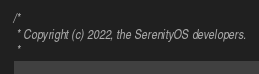Convert code to text. <code><loc_0><loc_0><loc_500><loc_500><_C++_>/*
 * Copyright (c) 2022, the SerenityOS developers.
 *</code> 